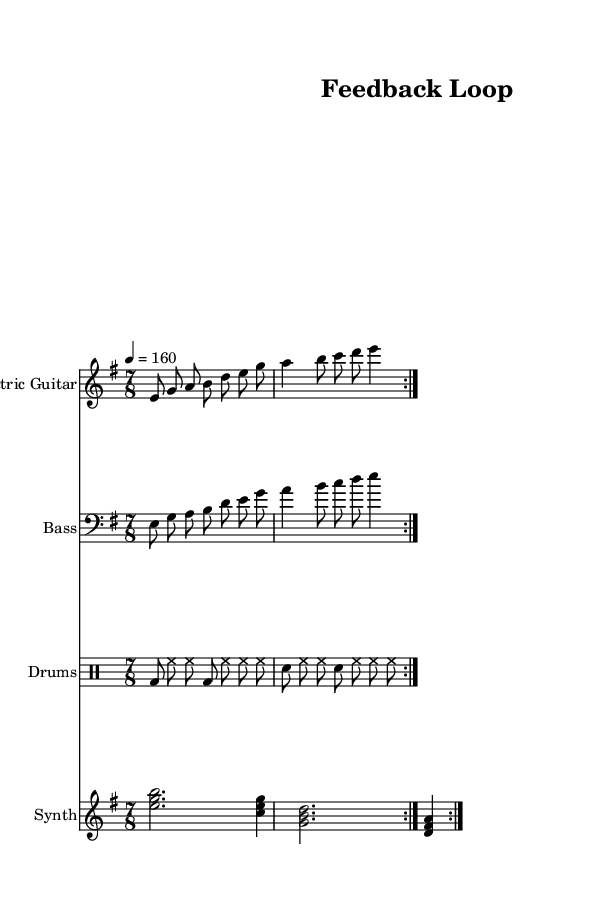What is the key signature of this music? The key signature indicated is E minor, which has one sharp (F#). This can be identified by looking at the key signature at the beginning of the music, where it shows one sharp.
Answer: E minor What is the time signature of this music? The time signature is 7/8, as shown right after the key signature. This signifies seven beats in each measure, with the eighth note getting one beat.
Answer: 7/8 What is the tempo marking for this music? The tempo marking is 4 = 160. This indicates that there are 160 beats per minute, and the quarter note is the note being counted for this tempo.
Answer: 160 How many measures are repeated in this piece? The music indicates a repeat marking (volta) for two measures, meaning it should be played through twice. This can be seen in the repeat symbol marking at the start and end of the repeated section.
Answer: 2 Which instrument is using a bass clef? The bass guitar part is written in a bass clef, which is used for lower-pitched instruments. This can be identified by the clef symbol at the beginning of the bass part.
Answer: Bass What is the primary rhythmic feel of the drums in this section? The drums maintain a steady eighth-note feel, combining bass drum and snare hits in patterns that create rhythmic complexity associated with progressive metal. This is evaluated by observing the drum rhythm and the division of beats on the drum staff.
Answer: Eighth-note What characterizes the guitar melody in this piece? The electric guitar features a combination of eighth notes and longer notes, emphasizing melodic progression typical in progressive metal. This is assessed by examining the note types and their arrangement in the guitar staff.
Answer: Melodic progression 